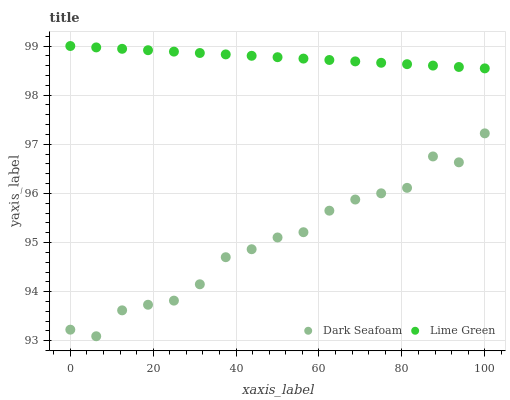Does Dark Seafoam have the minimum area under the curve?
Answer yes or no. Yes. Does Lime Green have the maximum area under the curve?
Answer yes or no. Yes. Does Lime Green have the minimum area under the curve?
Answer yes or no. No. Is Lime Green the smoothest?
Answer yes or no. Yes. Is Dark Seafoam the roughest?
Answer yes or no. Yes. Is Lime Green the roughest?
Answer yes or no. No. Does Dark Seafoam have the lowest value?
Answer yes or no. Yes. Does Lime Green have the lowest value?
Answer yes or no. No. Does Lime Green have the highest value?
Answer yes or no. Yes. Is Dark Seafoam less than Lime Green?
Answer yes or no. Yes. Is Lime Green greater than Dark Seafoam?
Answer yes or no. Yes. Does Dark Seafoam intersect Lime Green?
Answer yes or no. No. 